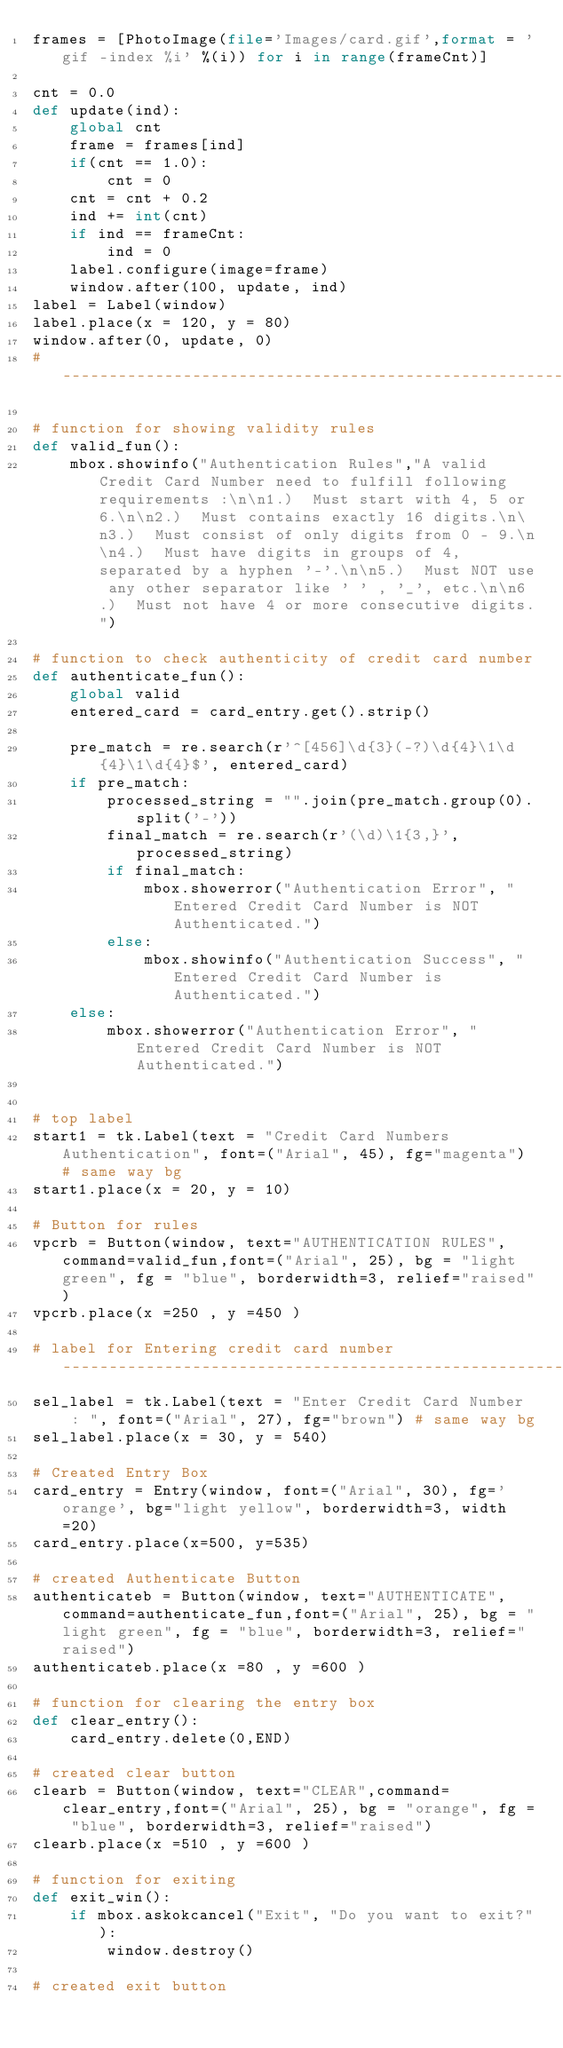Convert code to text. <code><loc_0><loc_0><loc_500><loc_500><_Python_>frames = [PhotoImage(file='Images/card.gif',format = 'gif -index %i' %(i)) for i in range(frameCnt)]

cnt = 0.0
def update(ind):
    global cnt
    frame = frames[ind]
    if(cnt == 1.0):
        cnt = 0
    cnt = cnt + 0.2
    ind += int(cnt)
    if ind == frameCnt:
        ind = 0
    label.configure(image=frame)
    window.after(100, update, ind)
label = Label(window)
label.place(x = 120, y = 80)
window.after(0, update, 0)
# --------------------------------------------------------------------

# function for showing validity rules
def valid_fun():
    mbox.showinfo("Authentication Rules","A valid Credit Card Number need to fulfill following requirements :\n\n1.)  Must start with 4, 5 or 6.\n\n2.)  Must contains exactly 16 digits.\n\n3.)  Must consist of only digits from 0 - 9.\n\n4.)  Must have digits in groups of 4, separated by a hyphen '-'.\n\n5.)  Must NOT use any other separator like ' ' , '_', etc.\n\n6.)  Must not have 4 or more consecutive digits.")

# function to check authenticity of credit card number
def authenticate_fun():
    global valid
    entered_card = card_entry.get().strip()

    pre_match = re.search(r'^[456]\d{3}(-?)\d{4}\1\d{4}\1\d{4}$', entered_card)
    if pre_match:
        processed_string = "".join(pre_match.group(0).split('-'))
        final_match = re.search(r'(\d)\1{3,}', processed_string)
        if final_match:
            mbox.showerror("Authentication Error", "Entered Credit Card Number is NOT Authenticated.")
        else:
            mbox.showinfo("Authentication Success", "Entered Credit Card Number is Authenticated.")
    else:
        mbox.showerror("Authentication Error", "Entered Credit Card Number is NOT Authenticated.")


# top label
start1 = tk.Label(text = "Credit Card Numbers Authentication", font=("Arial", 45), fg="magenta") # same way bg
start1.place(x = 20, y = 10)

# Button for rules
vpcrb = Button(window, text="AUTHENTICATION RULES",command=valid_fun,font=("Arial", 25), bg = "light green", fg = "blue", borderwidth=3, relief="raised")
vpcrb.place(x =250 , y =450 )

# label for Entering credit card number ---------------------------------------------------------------------------------
sel_label = tk.Label(text = "Enter Credit Card Number  : ", font=("Arial", 27), fg="brown") # same way bg
sel_label.place(x = 30, y = 540)

# Created Entry Box
card_entry = Entry(window, font=("Arial", 30), fg='orange', bg="light yellow", borderwidth=3, width=20)
card_entry.place(x=500, y=535)

# created Authenticate Button
authenticateb = Button(window, text="AUTHENTICATE",command=authenticate_fun,font=("Arial", 25), bg = "light green", fg = "blue", borderwidth=3, relief="raised")
authenticateb.place(x =80 , y =600 )

# function for clearing the entry box
def clear_entry():
    card_entry.delete(0,END)

# created clear button
clearb = Button(window, text="CLEAR",command=clear_entry,font=("Arial", 25), bg = "orange", fg = "blue", borderwidth=3, relief="raised")
clearb.place(x =510 , y =600 )

# function for exiting
def exit_win():
    if mbox.askokcancel("Exit", "Do you want to exit?"):
        window.destroy()

# created exit button</code> 